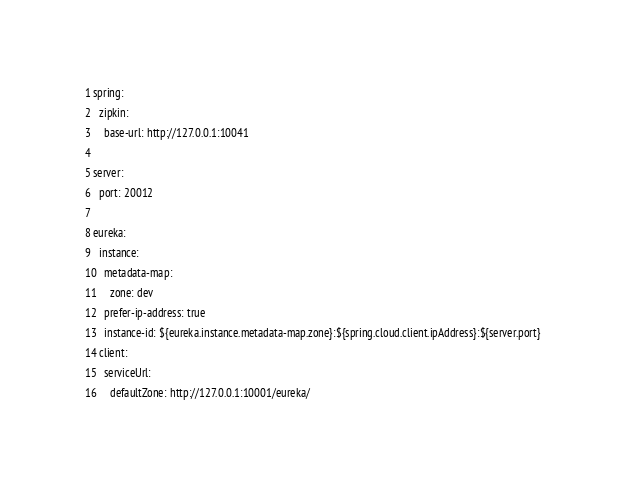<code> <loc_0><loc_0><loc_500><loc_500><_YAML_>spring:
  zipkin:
    base-url: http://127.0.0.1:10041

server:
  port: 20012

eureka:
  instance:
    metadata-map:
      zone: dev
    prefer-ip-address: true
    instance-id: ${eureka.instance.metadata-map.zone}:${spring.cloud.client.ipAddress}:${server.port}
  client:
    serviceUrl:
      defaultZone: http://127.0.0.1:10001/eureka/</code> 